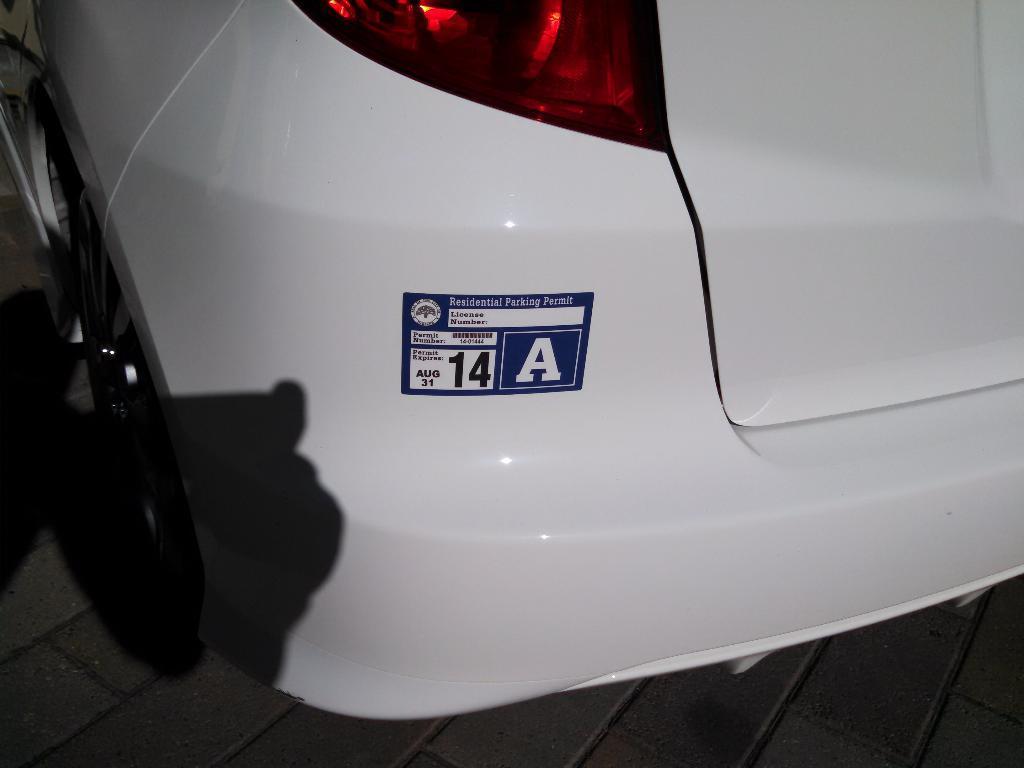Could you give a brief overview of what you see in this image? There is a truncated back side view of a car on the ground and the shadow on it. 